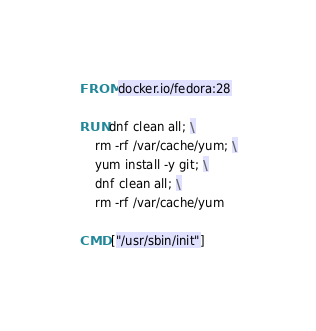<code> <loc_0><loc_0><loc_500><loc_500><_Dockerfile_>FROM docker.io/fedora:28

RUN dnf clean all; \
    rm -rf /var/cache/yum; \
    yum install -y git; \
    dnf clean all; \
    rm -rf /var/cache/yum

CMD ["/usr/sbin/init"]</code> 